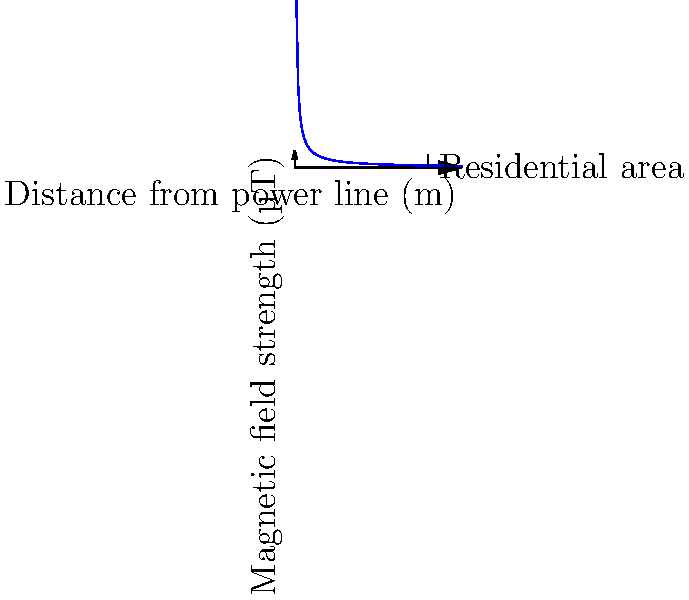A high-voltage power line is proposed near a residential area. Given the graph showing the relationship between distance from the power line and magnetic field strength, at what minimum distance should residential buildings be placed to ensure the magnetic field strength is below 1 µT? To solve this problem, we need to follow these steps:

1. Understand the graph:
   - The x-axis represents the distance from the power line in meters.
   - The y-axis represents the magnetic field strength in microteslas (µT).
   - The curve shows an inverse relationship between distance and field strength.

2. Identify the target magnetic field strength:
   - We need to find the distance where the field strength is 1 µT or less.

3. Use the equation of the curve:
   - The curve follows the equation $B = \frac{100}{d}$, where $B$ is the magnetic field strength in µT and $d$ is the distance in meters.

4. Solve for the distance:
   - We want $B \leq 1$ µT
   - Substituting into the equation: $1 = \frac{100}{d}$
   - Solving for $d$: $d = \frac{100}{1} = 100$ meters

5. Verify on the graph:
   - We can see that at 100 meters, the curve intersects the 1 µT line.

Therefore, residential buildings should be placed at least 100 meters away from the power line to ensure the magnetic field strength is below 1 µT.
Answer: 100 meters 